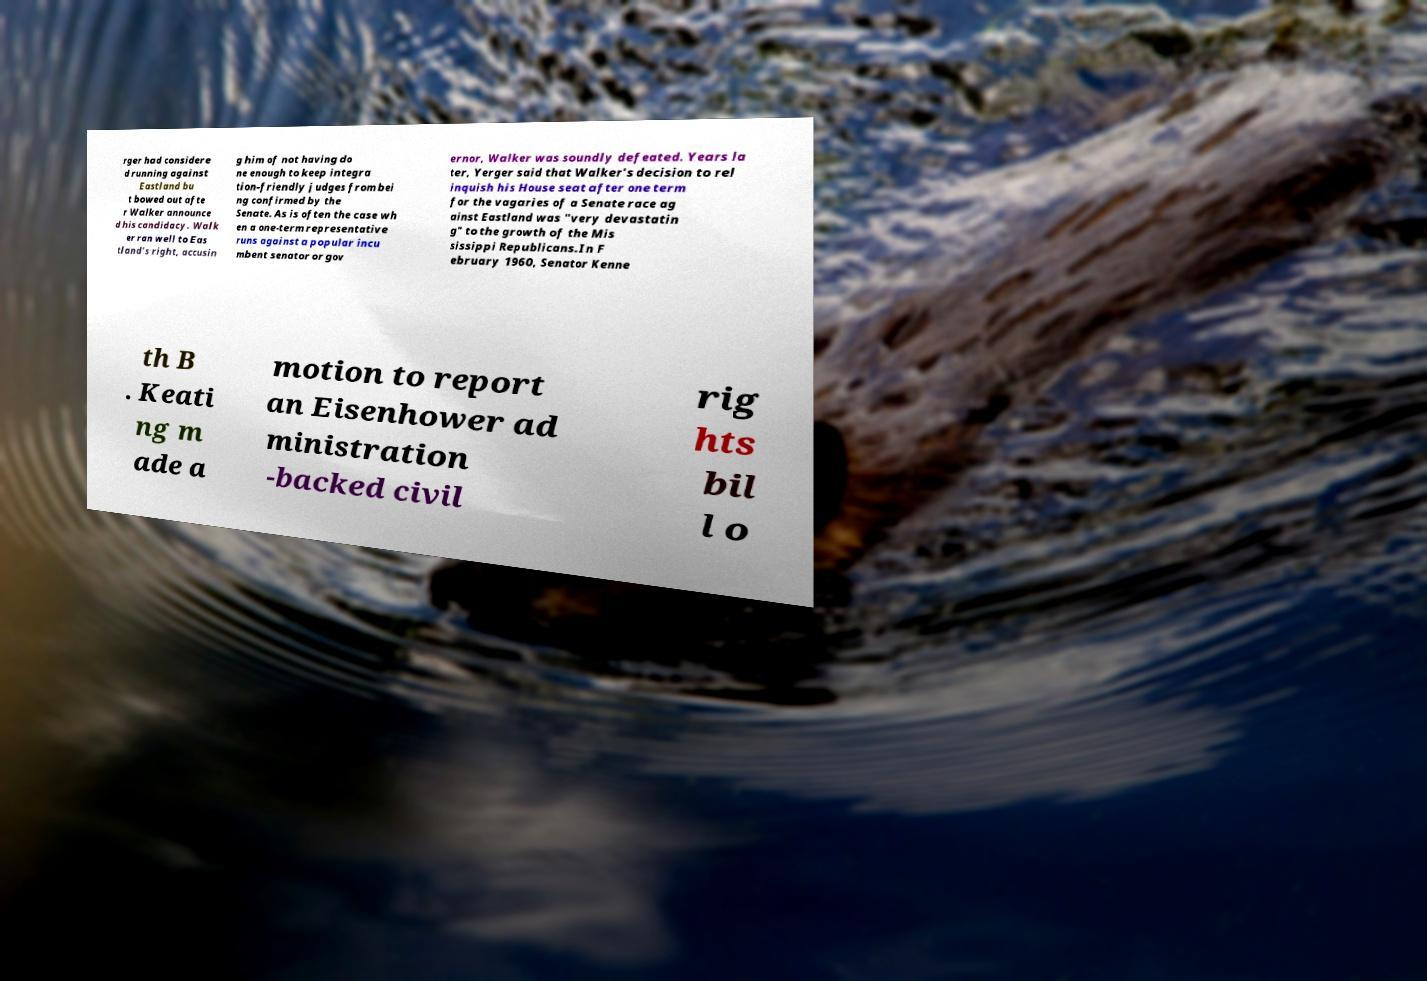Please identify and transcribe the text found in this image. rger had considere d running against Eastland bu t bowed out afte r Walker announce d his candidacy. Walk er ran well to Eas tland's right, accusin g him of not having do ne enough to keep integra tion-friendly judges from bei ng confirmed by the Senate. As is often the case wh en a one-term representative runs against a popular incu mbent senator or gov ernor, Walker was soundly defeated. Years la ter, Yerger said that Walker's decision to rel inquish his House seat after one term for the vagaries of a Senate race ag ainst Eastland was "very devastatin g" to the growth of the Mis sissippi Republicans.In F ebruary 1960, Senator Kenne th B . Keati ng m ade a motion to report an Eisenhower ad ministration -backed civil rig hts bil l o 